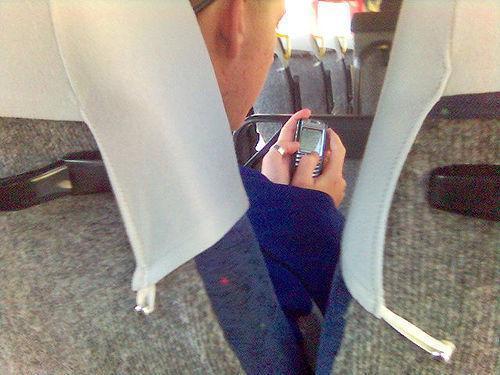How many dogs are in the image?
Give a very brief answer. 0. 